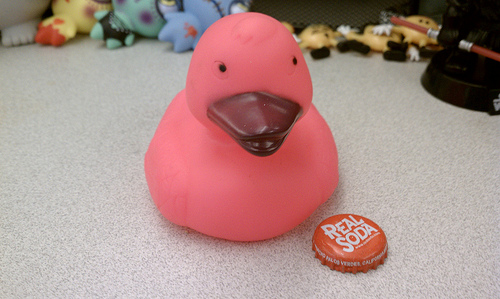<image>
Is there a rubber duck on the bottle cap? No. The rubber duck is not positioned on the bottle cap. They may be near each other, but the rubber duck is not supported by or resting on top of the bottle cap. Is the duck behind the bottle cap? Yes. From this viewpoint, the duck is positioned behind the bottle cap, with the bottle cap partially or fully occluding the duck. Where is the toy duck in relation to the blue toy? Is it next to the blue toy? No. The toy duck is not positioned next to the blue toy. They are located in different areas of the scene. Is the duck in front of the bottle cap? No. The duck is not in front of the bottle cap. The spatial positioning shows a different relationship between these objects. 